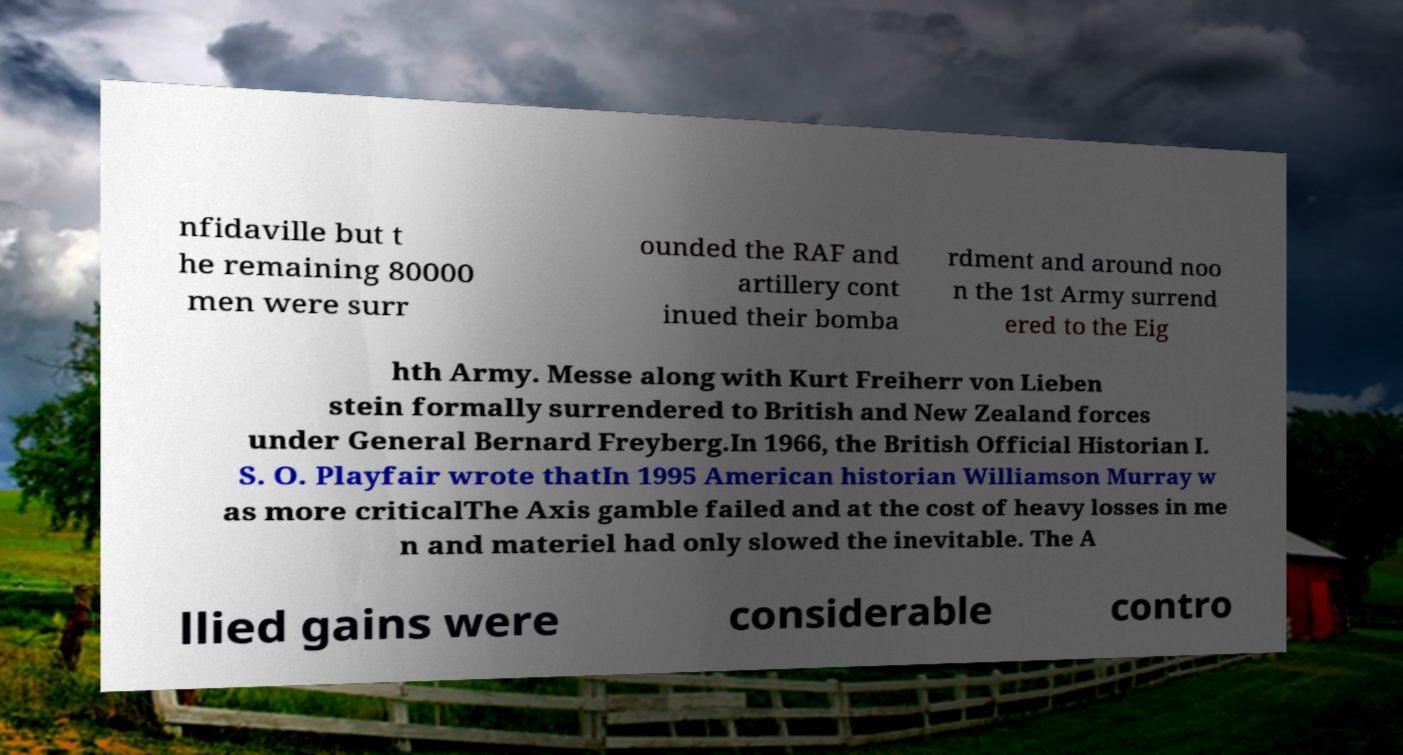Please identify and transcribe the text found in this image. nfidaville but t he remaining 80000 men were surr ounded the RAF and artillery cont inued their bomba rdment and around noo n the 1st Army surrend ered to the Eig hth Army. Messe along with Kurt Freiherr von Lieben stein formally surrendered to British and New Zealand forces under General Bernard Freyberg.In 1966, the British Official Historian I. S. O. Playfair wrote thatIn 1995 American historian Williamson Murray w as more criticalThe Axis gamble failed and at the cost of heavy losses in me n and materiel had only slowed the inevitable. The A llied gains were considerable contro 